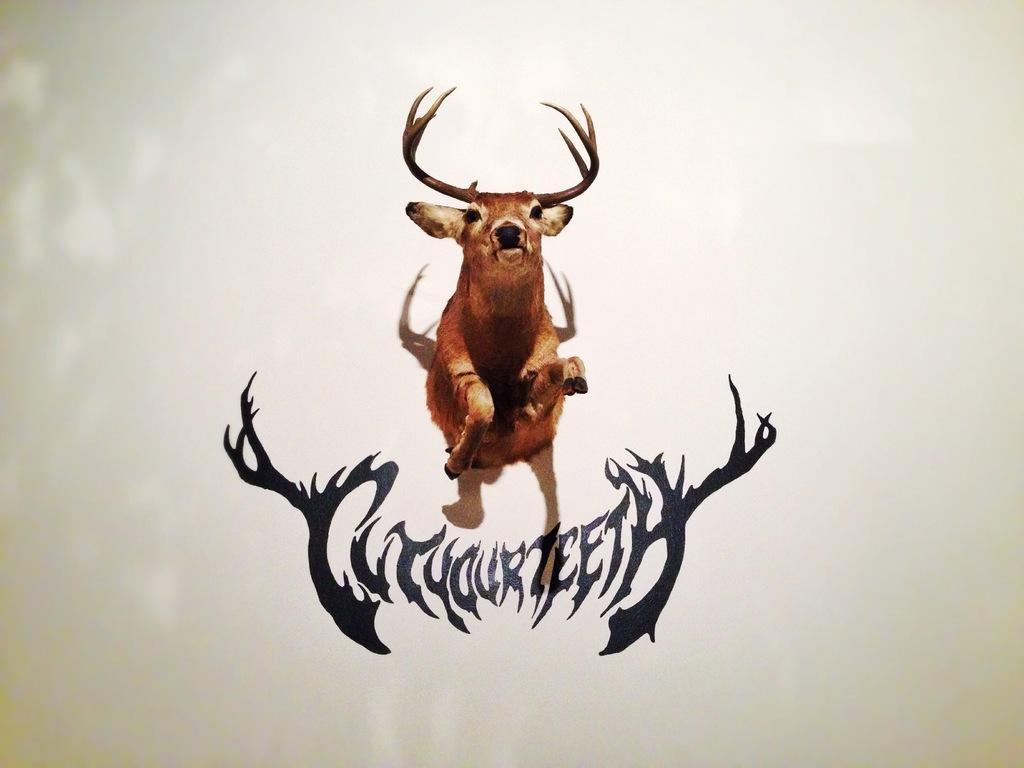In one or two sentences, can you explain what this image depicts? In the image we can see a deer in jumping position. There is a text and the background is white. 